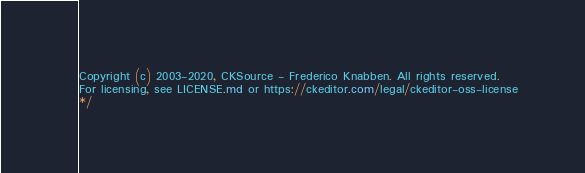<code> <loc_0><loc_0><loc_500><loc_500><_CSS_>Copyright (c) 2003-2020, CKSource - Frederico Knabben. All rights reserved.
For licensing, see LICENSE.md or https://ckeditor.com/legal/ckeditor-oss-license
*/</code> 